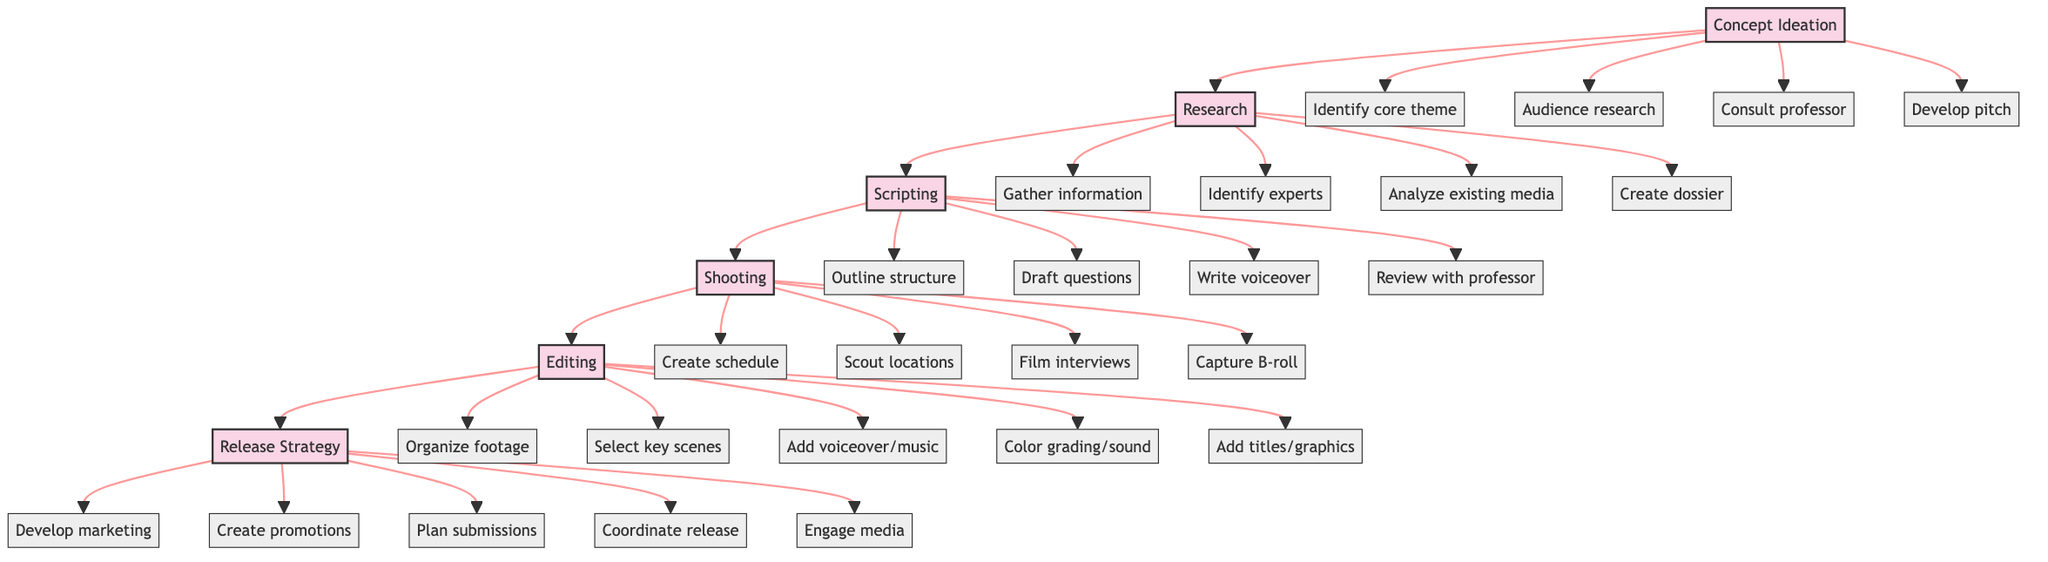What is the first stage in the documentary film creation process? The first stage listed in the diagram is indicated as "Concept Ideation." There are arrows showing the flow that begins with this stage.
Answer: Concept Ideation How many total stages are illustrated in the flow chart? The diagram shows six stages with the use of letters for each stage (A, B, C, D, E, F), making a total of six stages that are connected sequentially.
Answer: 6 What is the last element in the "Editing" stage? The last element listed under "Editing" in the diagram is "Add titles and graphics." Since each stage has multiple elements listed below them, this is simply the last one mentioned for the Editing stage.
Answer: Add titles and graphics Which stage involves collaborating with a sociology professor? The stage "Concept Ideation" includes the element "Consult with sociology professor for societal impact insights," indicating this is where collaboration occurs.
Answer: Concept Ideation What are two activities included in the "Shooting" stage? The diagram outlines several activities within the "Shooting" stage. Notably, "Conduct and film interviews" and "Capture B-roll and supplementary footage" are highlighted as activities during this stage, showcasing the work performed here.
Answer: Conduct and film interviews, Capture B-roll and supplementary footage In which stage is the "Develop marketing" element found? The element "Develop a marketing plan" is located in the final stage, "Release Strategy," as per the flow chart's organization. This indicates that marketing efforts occur at the end of the documentary project.
Answer: Release Strategy Which stage comes immediately after "Research"? Following the diagram flow, "Scripting" is the stage that comes directly after "Research." The flow lines between the stages indicate their sequential relationship.
Answer: Scripting How many elements are listed under the "Research" stage? The "Research" stage contains four distinct elements described in the diagram. They are displayed one after another under the associated stage label.
Answer: 4 